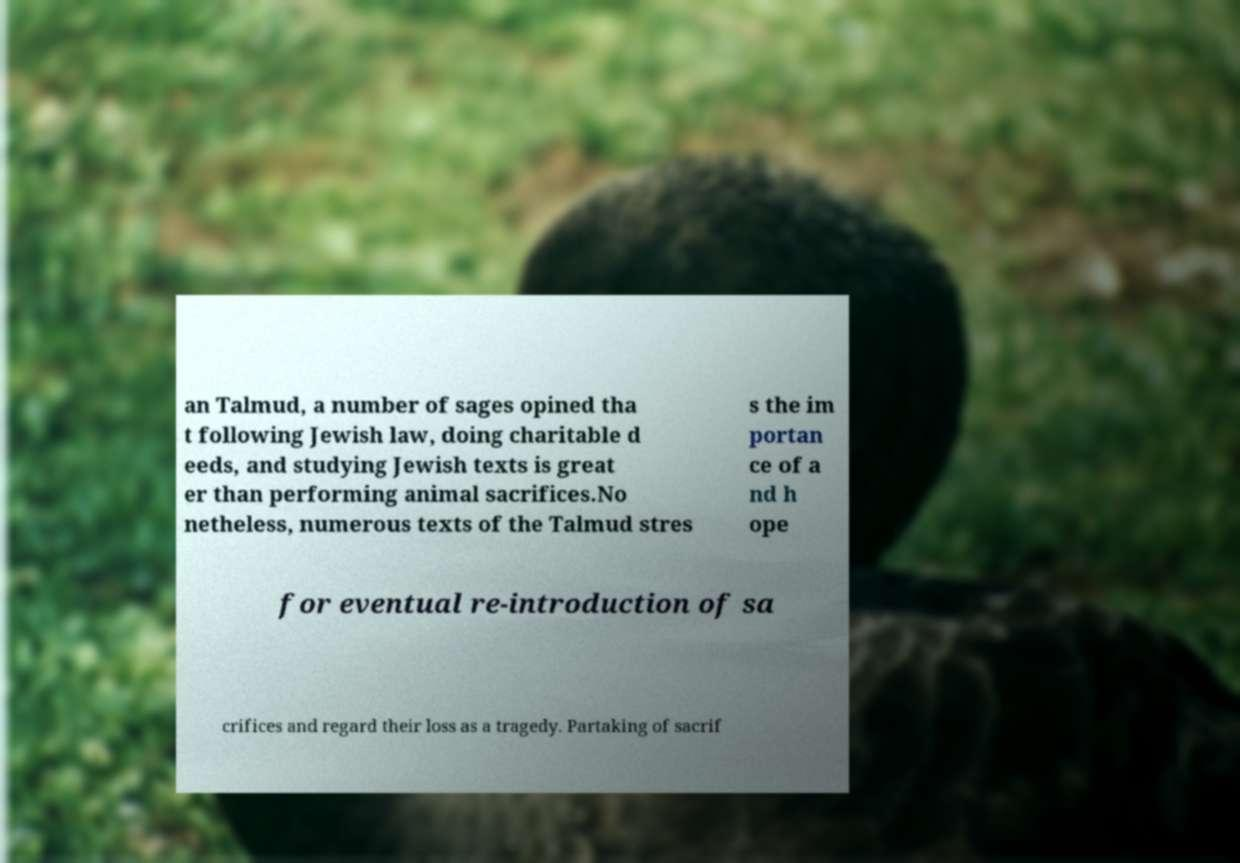Can you accurately transcribe the text from the provided image for me? an Talmud, a number of sages opined tha t following Jewish law, doing charitable d eeds, and studying Jewish texts is great er than performing animal sacrifices.No netheless, numerous texts of the Talmud stres s the im portan ce of a nd h ope for eventual re-introduction of sa crifices and regard their loss as a tragedy. Partaking of sacrif 